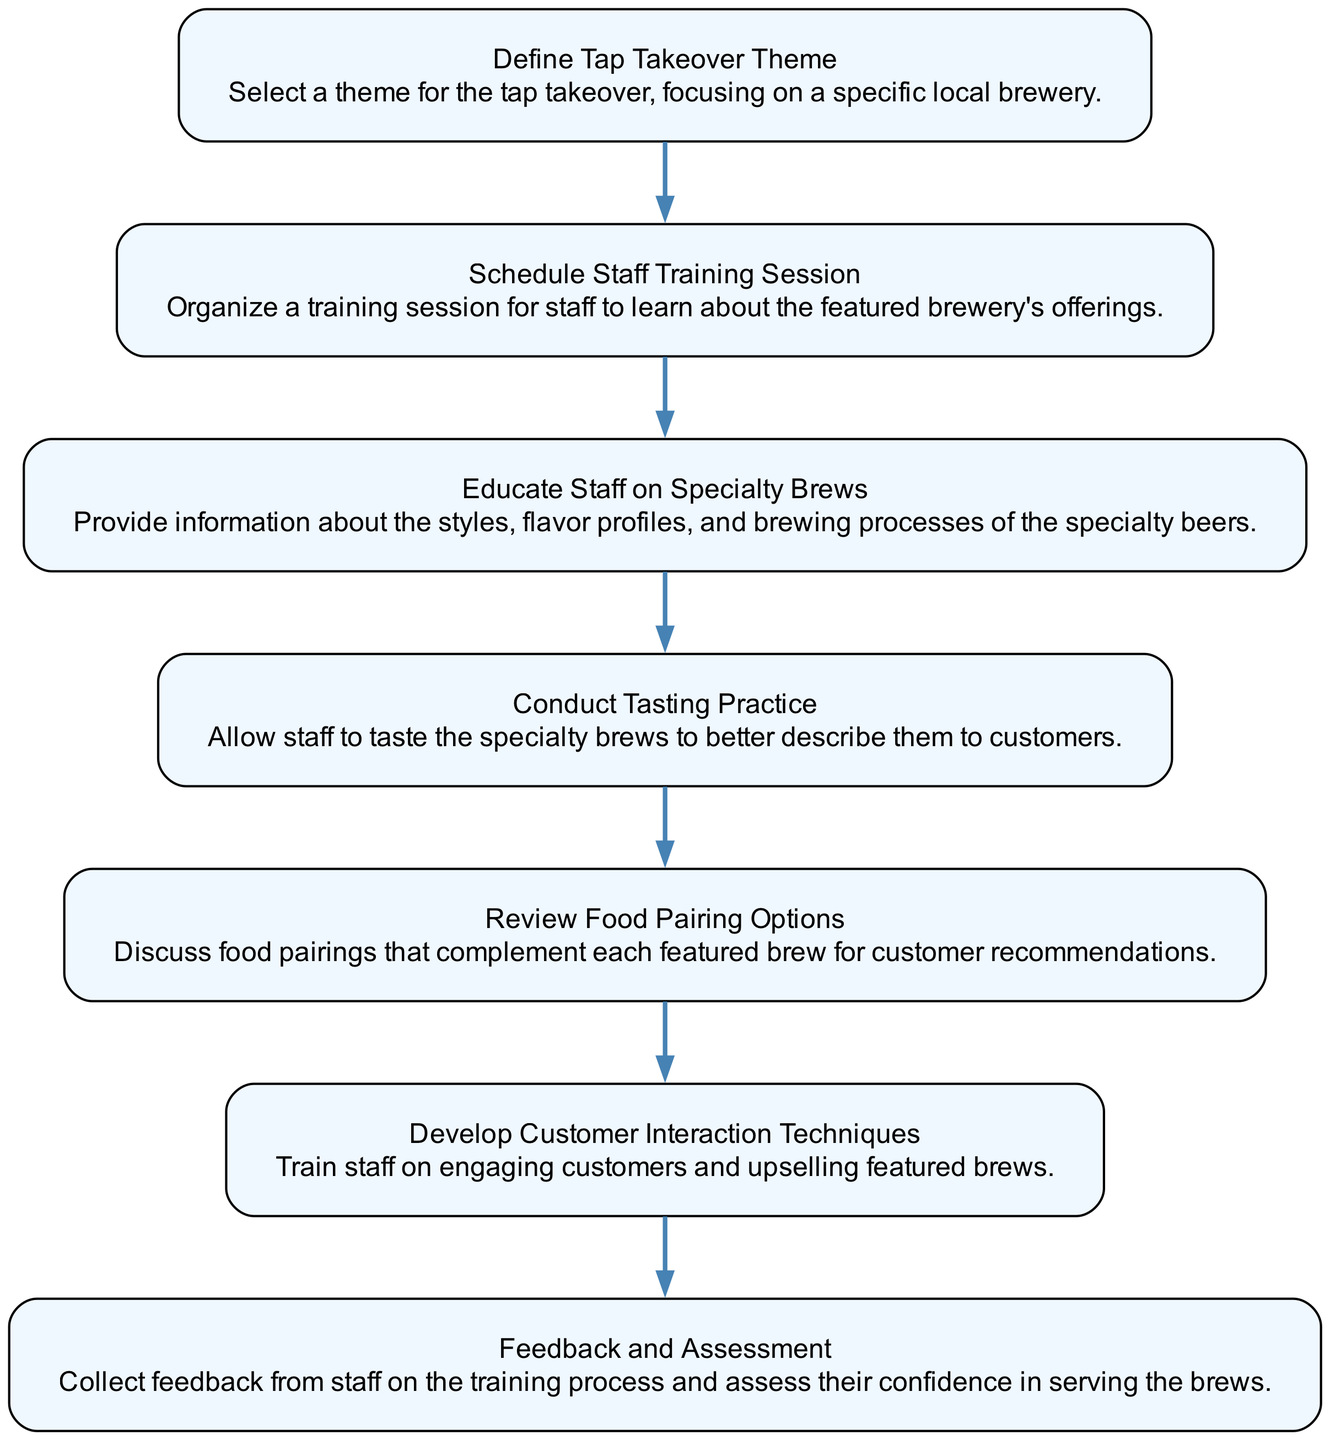What is the first step in the training process? The flow chart indicates that the first step is “Define Tap Takeover Theme.” This is the first node listed in the diagram, which starts the entire training process.
Answer: Define Tap Takeover Theme How many nodes are present in the diagram? By counting each step represented in the flow chart, we find there are seven distinct nodes, each corresponding to a part of the training process.
Answer: 7 Which step involves staff tasting the specialty brews? The diagram shows that the step titled “Conduct Tasting Practice” specifically mentions allowing staff to taste the specialty beers. This is directly related to understanding the brews better.
Answer: Conduct Tasting Practice What step follows “Schedule Staff Training Session”? According to the flow direction in the diagram, “Educate Staff on Specialty Brews” is the step that directly follows “Schedule Staff Training Session.” This shows that staff education comes right after scheduling the training.
Answer: Educate Staff on Specialty Brews Which two steps are crucial for customer interaction skills? The diagram links the steps “Develop Customer Interaction Techniques” and incorporates feedback gathered, which helps to assess how well staff can engage with customers and upsell products. Both together enhance interaction skills significantly.
Answer: Develop Customer Interaction Techniques and Feedback and Assessment What is the last step in the training process? Observing the flow in the diagram, we see that the last step is “Feedback and Assessment,” which occurs after all training and education efforts have been implemented.
Answer: Feedback and Assessment How many direct connections (edges) are in the diagram? Each step connects to the next, and by counting the connections visually, we find there are six edges, indicating the flow from the first to the last step.
Answer: 6 What is the purpose of the “Review Food Pairing Options” step? This step focuses on discussing food pairings that enhance the experience with each featured brew. It’s aimed at equipping staff to make recommendations to customers, thereby enriching their service skills.
Answer: Discuss food pairings that complement each featured brew What does the “Feedback and Assessment” step gather? This step collects feedback from staff regarding the training process and assesses their confidence levels, which is crucial to ensure staff feel prepared to serve the brews effectively.
Answer: Feedback on the training process and confidence assessment 